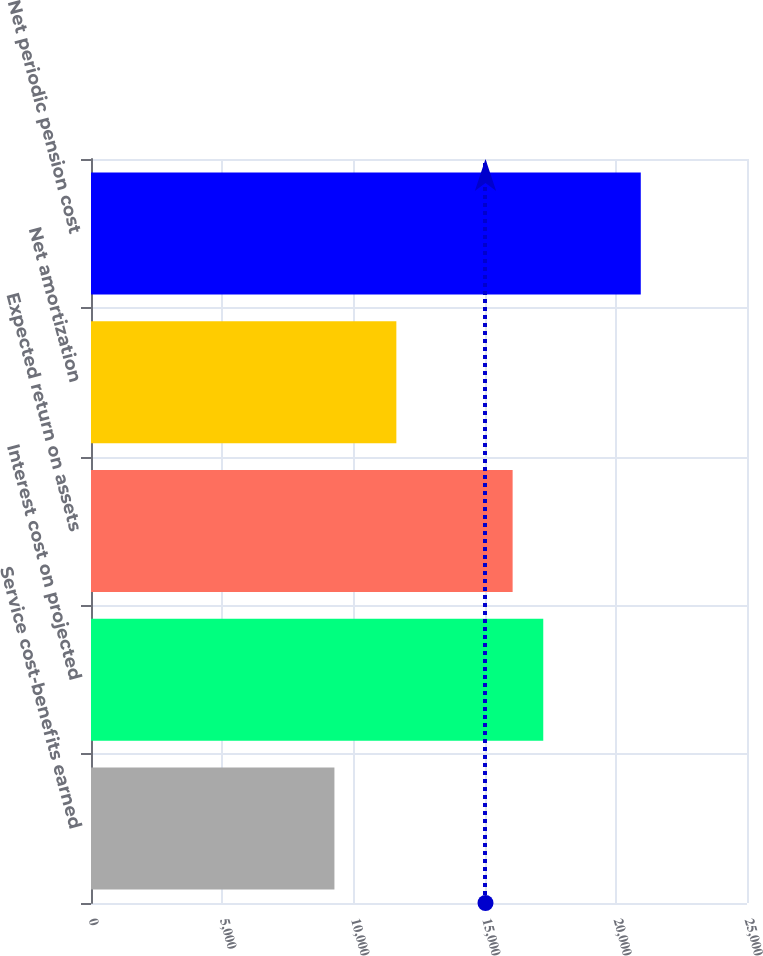<chart> <loc_0><loc_0><loc_500><loc_500><bar_chart><fcel>Service cost-benefits earned<fcel>Interest cost on projected<fcel>Expected return on assets<fcel>Net amortization<fcel>Net periodic pension cost<nl><fcel>9277<fcel>17235.5<fcel>16068<fcel>11637<fcel>20952<nl></chart> 